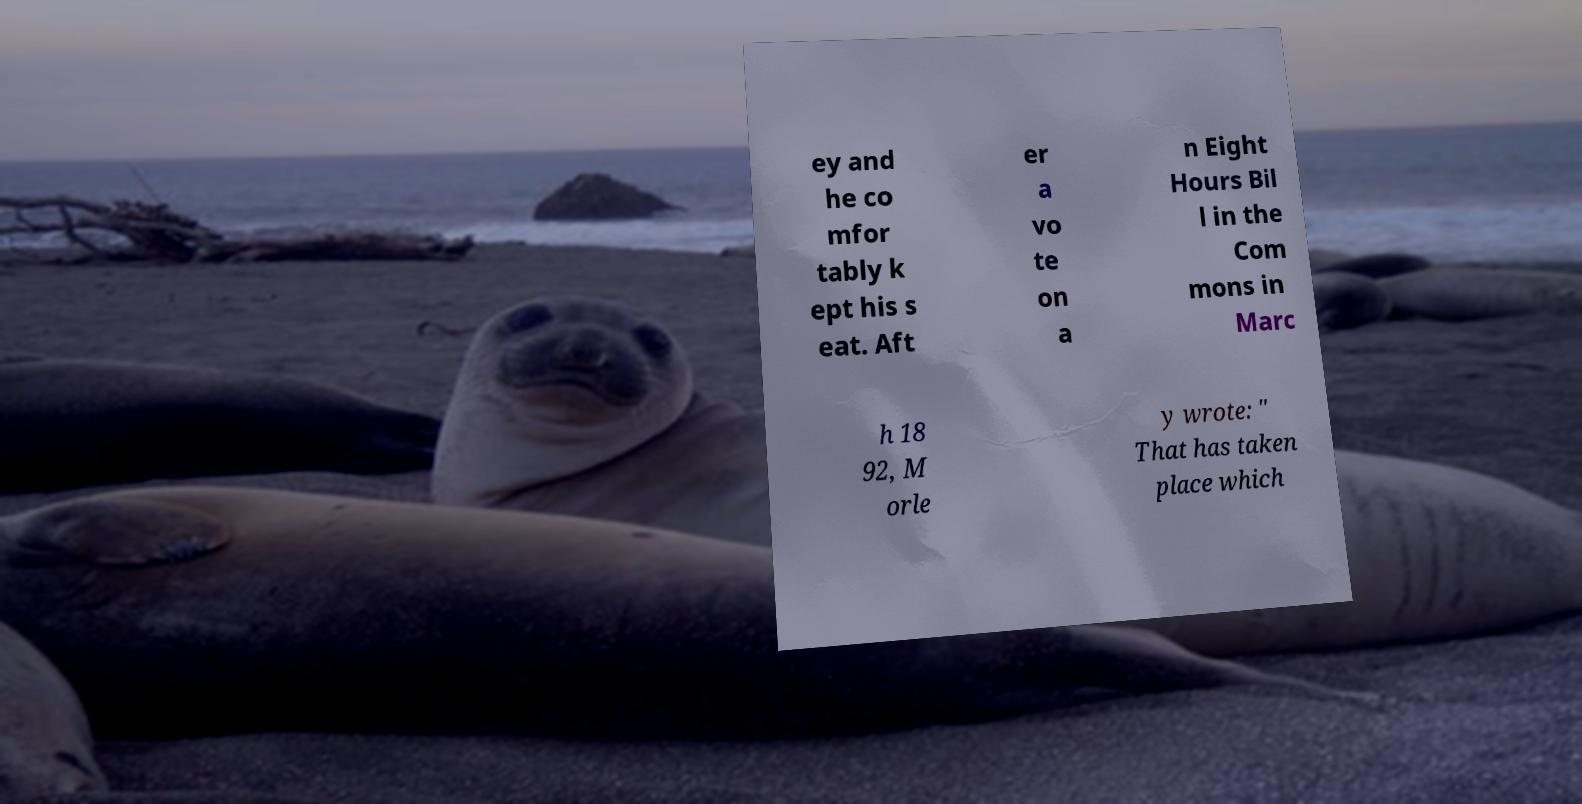Can you read and provide the text displayed in the image?This photo seems to have some interesting text. Can you extract and type it out for me? ey and he co mfor tably k ept his s eat. Aft er a vo te on a n Eight Hours Bil l in the Com mons in Marc h 18 92, M orle y wrote: " That has taken place which 